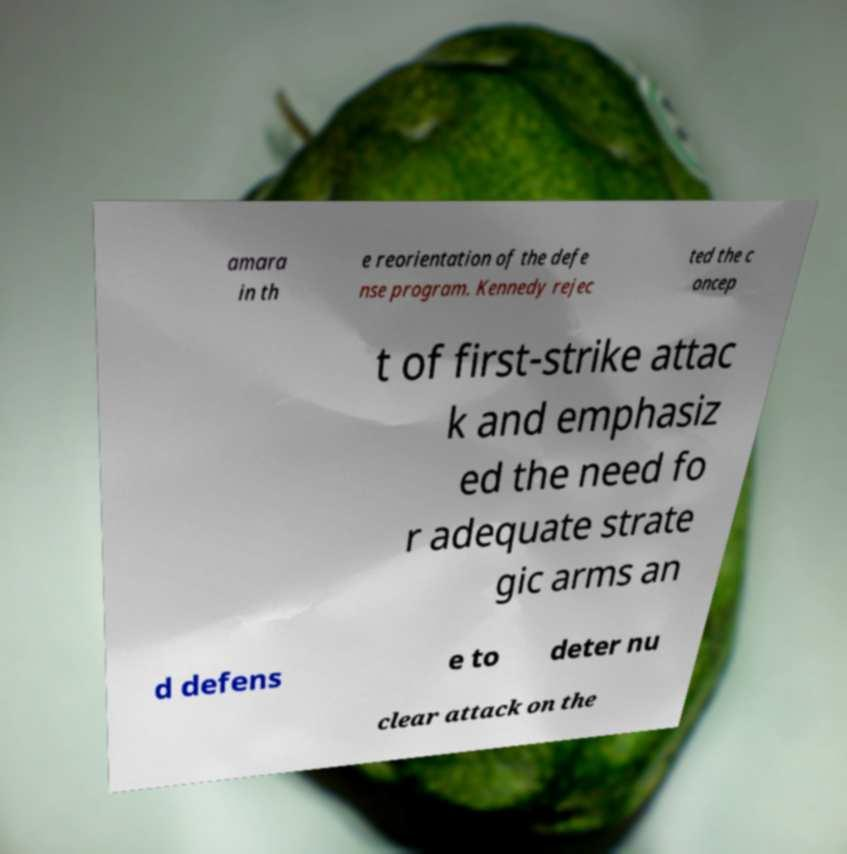Could you assist in decoding the text presented in this image and type it out clearly? amara in th e reorientation of the defe nse program. Kennedy rejec ted the c oncep t of first-strike attac k and emphasiz ed the need fo r adequate strate gic arms an d defens e to deter nu clear attack on the 